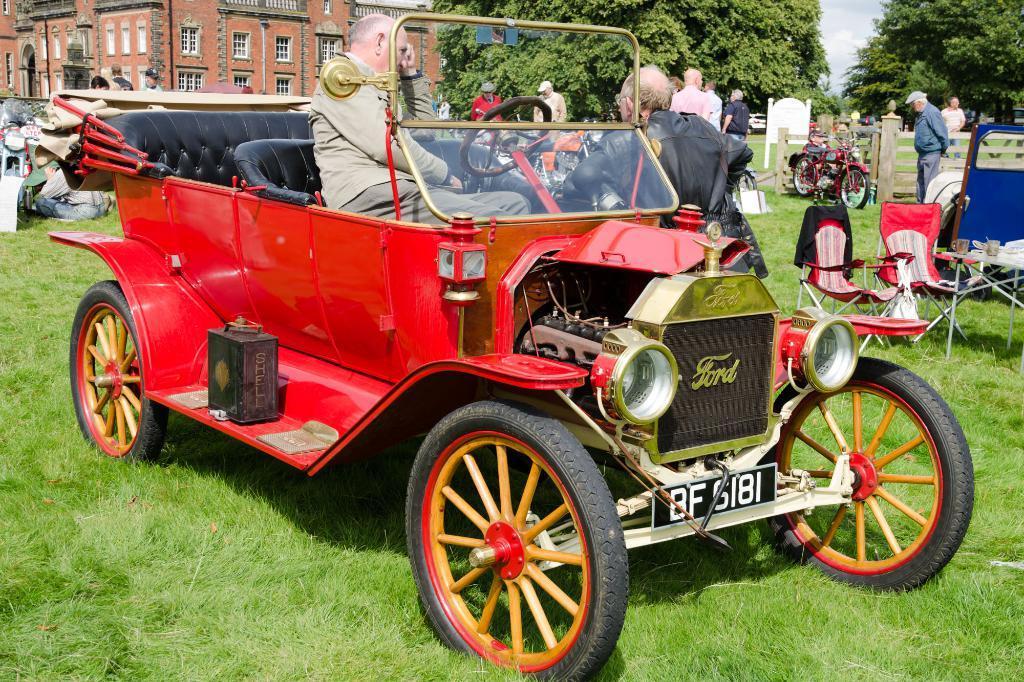Please provide a concise description of this image. In this image there are group of persons. In the right side there is a table and two chairs and a person is standing in the center the man wearing a black colour jacket is leaning on the car and a person is sitting in the car. On the left side the man is sitting on the grass and on the car there is word written as ford bf 6181. In the background there are trees, sky on the left side there is a building with red colour bricks and white colour window. In the center there is a bike which is red in colour. 